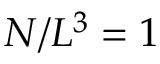Convert formula to latex. <formula><loc_0><loc_0><loc_500><loc_500>N / L ^ { 3 } = 1</formula> 